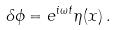Convert formula to latex. <formula><loc_0><loc_0><loc_500><loc_500>\delta \phi = e ^ { i \omega t } \eta ( x ) \, .</formula> 